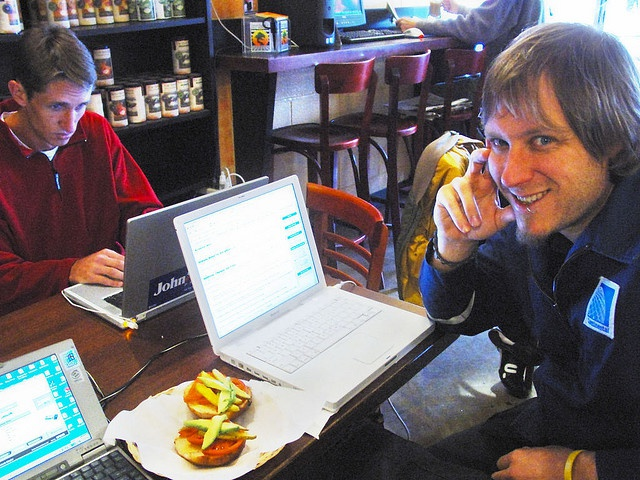Describe the objects in this image and their specific colors. I can see dining table in black, white, gray, and maroon tones, people in black, gray, brown, and navy tones, people in black, maroon, gray, and brown tones, laptop in black, white, darkgray, lightblue, and lightgray tones, and laptop in black, white, cyan, lightblue, and gray tones in this image. 